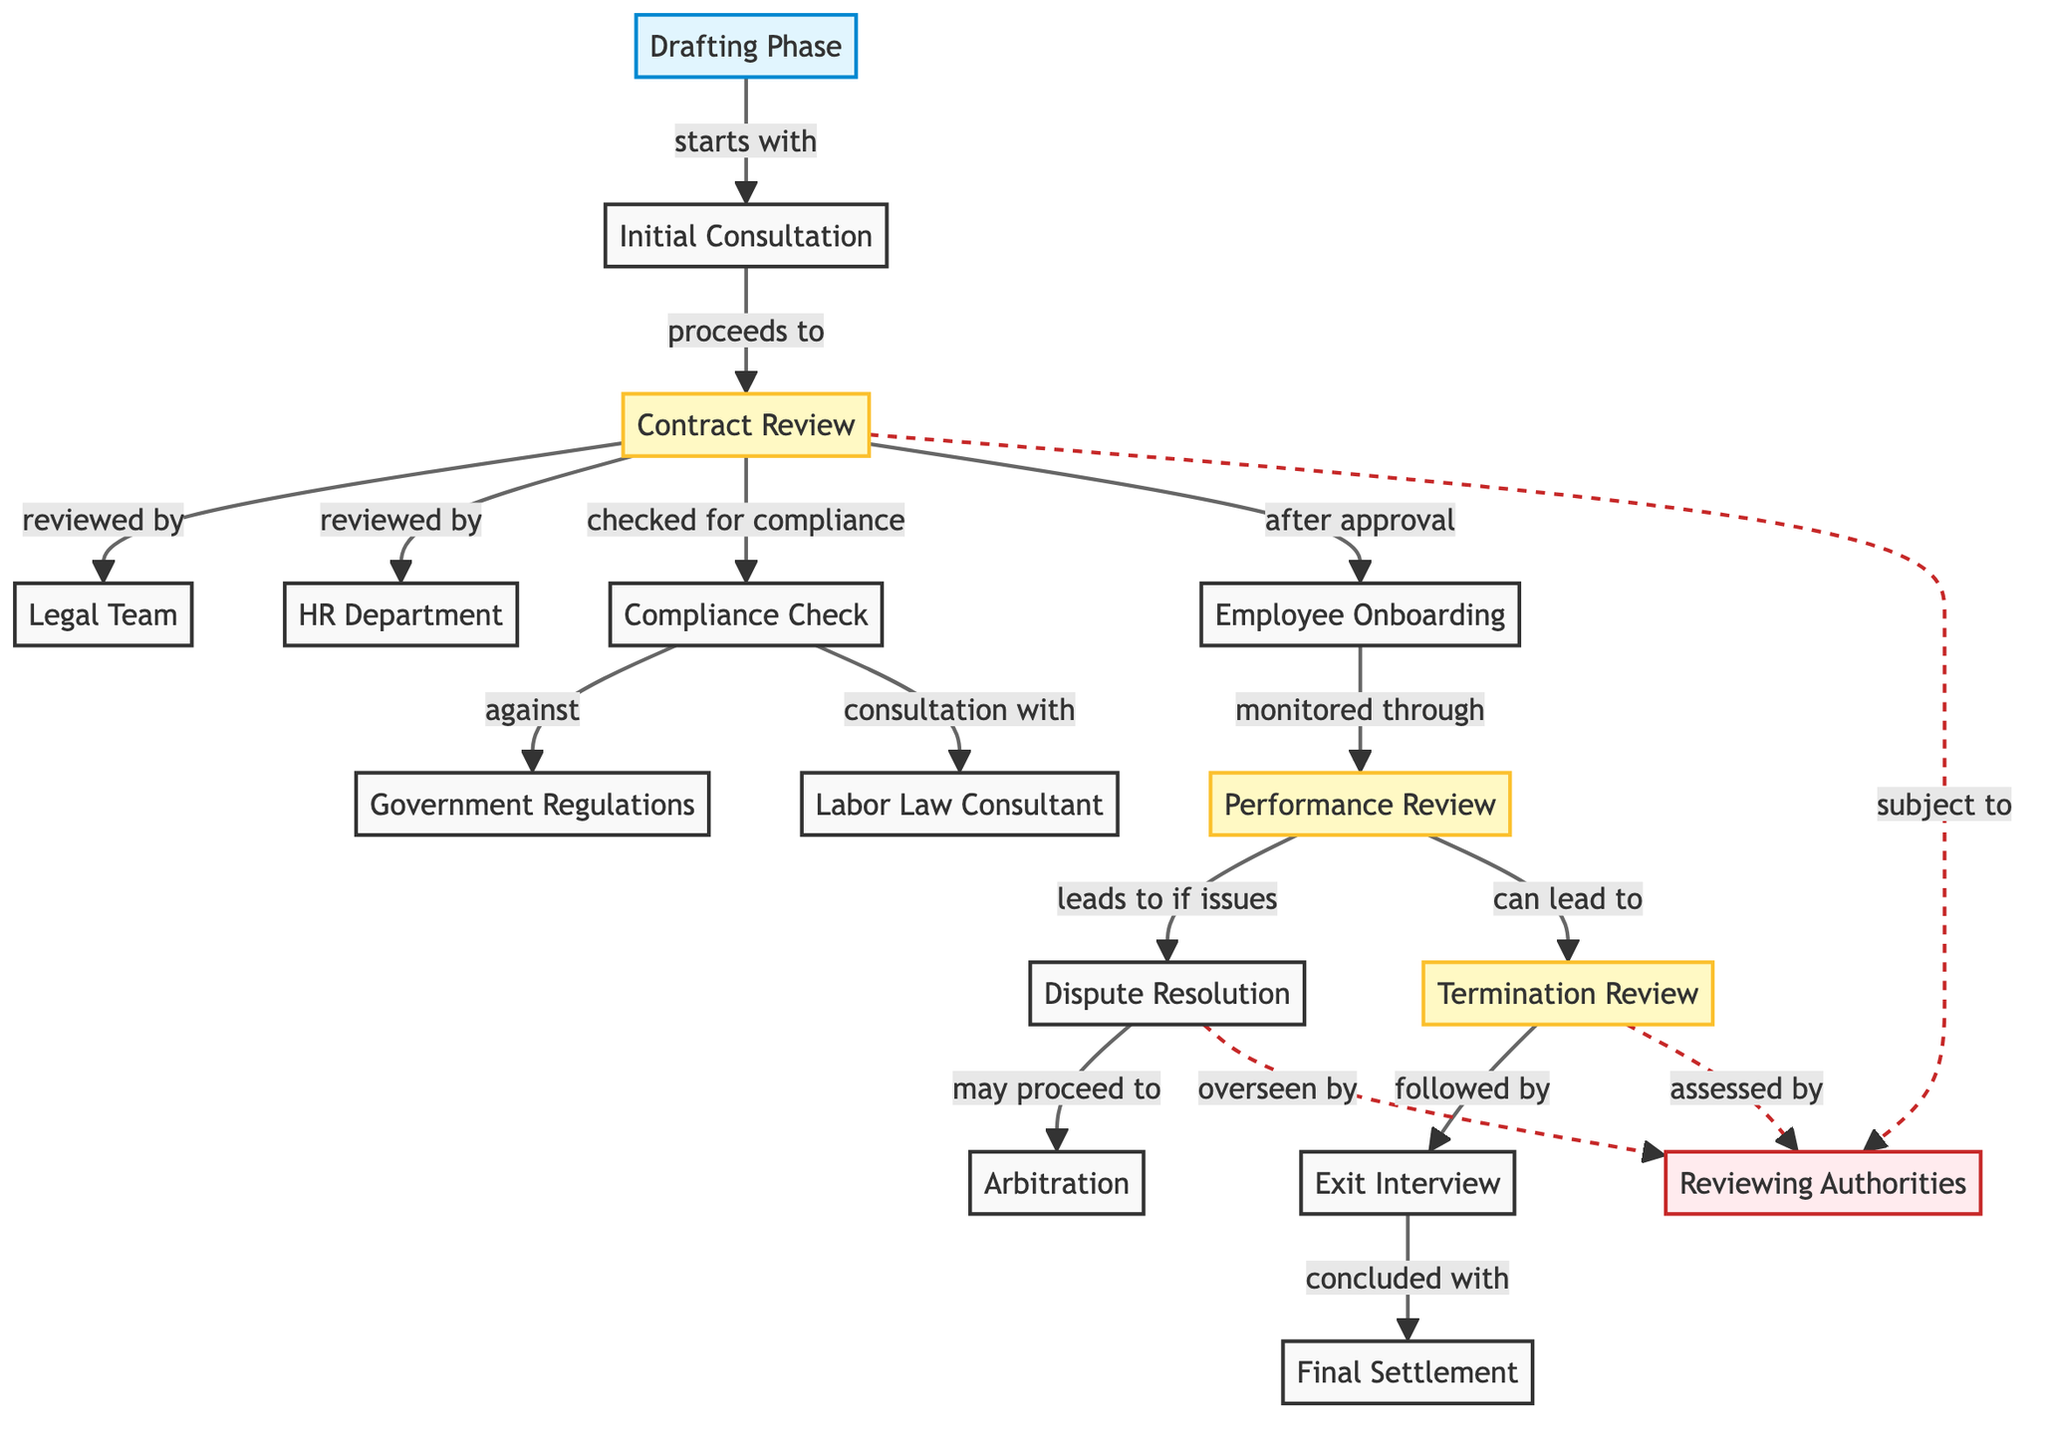What is the first phase of the employment contract lifecycle? The diagram starts with the "Drafting Phase" node, which indicates that this is the initial phase of the employment contract lifecycle.
Answer: Drafting Phase How many reviewing authorities are specified in the diagram? The diagram includes one node labeled "Reviewing Authorities," confirming there is only one specified reviewing authority in the process.
Answer: 1 Which phase leads to Employee Onboarding? The "Contract Review" phase directly leads to "Employee Onboarding," as indicated by the connecting arrow labeled "after approval."
Answer: Contract Review What are the two departments that review the contract? The "Contract Review" node is connected to both the "Legal Team" and "HR Department" nodes, indicating that these are the two departments responsible for reviewing the contract.
Answer: Legal Team, HR Department What follows the Termination Review phase? According to the diagram, the "Exit Interview" phase directly follows the "Termination Review," as indicated by the connecting arrow labeled "followed by."
Answer: Exit Interview If a dispute arises, which process may it lead to? The arrow from the "Dispute Resolution" node indicates that if issues arise during the "Performance Review," it may lead to "Arbitration."
Answer: Arbitration What checks the contract for compliance? The "Compliance Check" node is directly linked to the "Contract Review" node, indicating that this phase checks the contract for compliance.
Answer: Compliance Check Which authority oversees the Dispute Resolution process? The "Reviewing Authorities" node is connected to the "Dispute Resolution" node, showing that this authority oversees the dispute resolution process.
Answer: Reviewing Authorities What is concluded after the Exit Interview? The last phase in the diagram is "Final Settlement," which is directly concluded after the "Exit Interview," as shown by the connecting arrow labeled "concluded with."
Answer: Final Settlement 